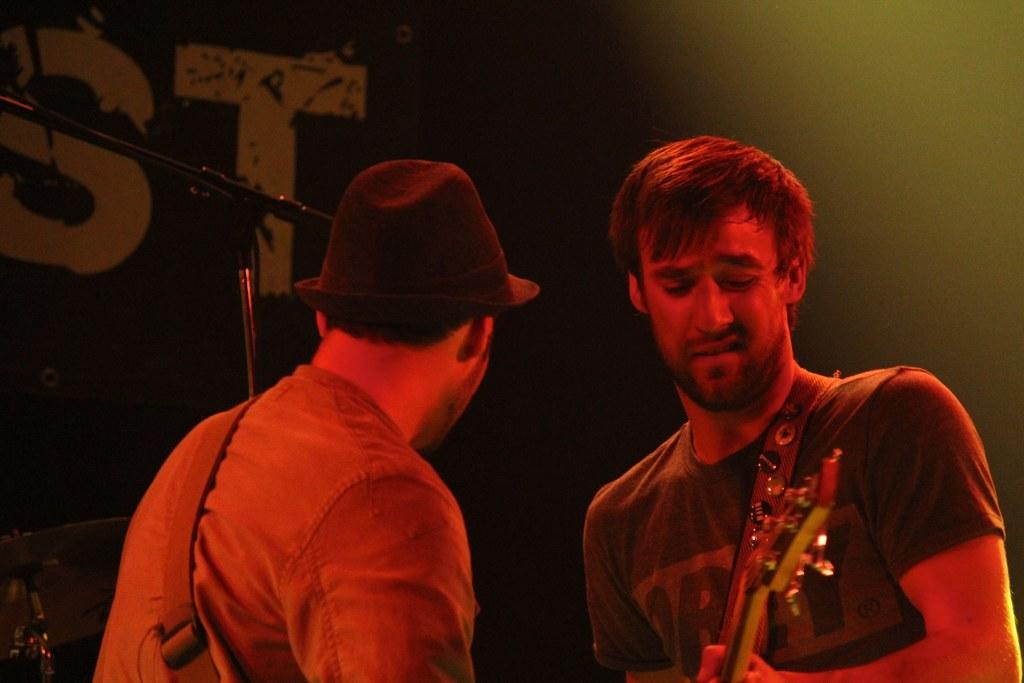How many people are in the image? There are two people in the image. What are the people doing in the image? One of the people is holding a musical instrument. What type of quartz is present on the nightstand in the image? There is no quartz or nightstand present in the image; it only features two people, one of whom is holding a musical instrument. 